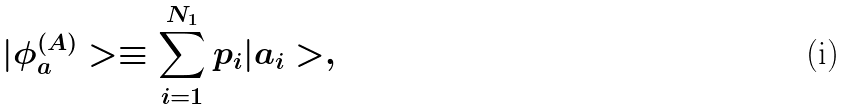<formula> <loc_0><loc_0><loc_500><loc_500>| \phi ^ { ( A ) } _ { a } > \equiv \sum _ { i = 1 } ^ { N _ { 1 } } p _ { i } | a _ { i } > ,</formula> 